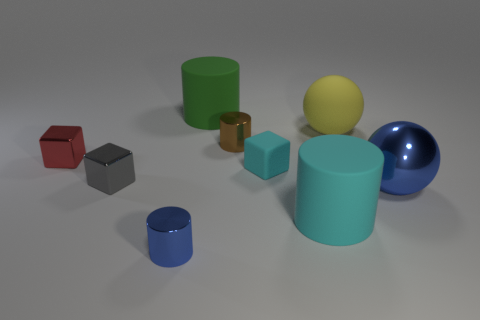Subtract all spheres. How many objects are left? 7 Add 7 cyan rubber blocks. How many cyan rubber blocks exist? 8 Subtract 1 cyan cubes. How many objects are left? 8 Subtract all tiny green metal cylinders. Subtract all spheres. How many objects are left? 7 Add 3 tiny cyan cubes. How many tiny cyan cubes are left? 4 